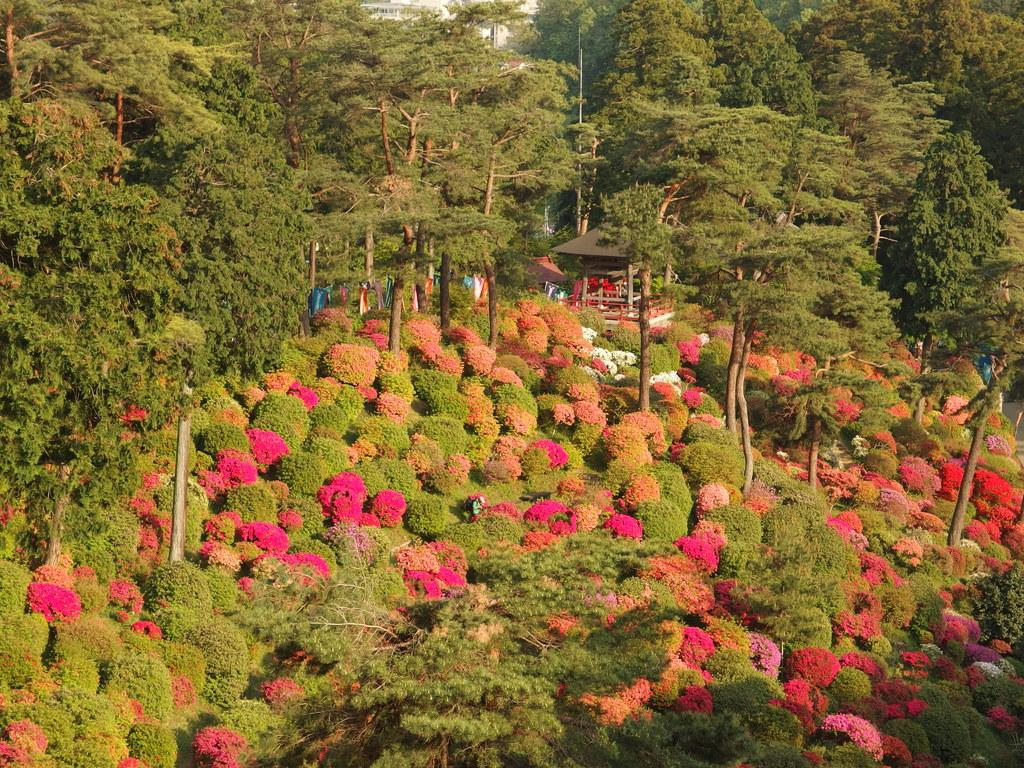What type of location is shown in the image? The image depicts a garden. What can be seen at the bottom of the image? There are many flower plants at the bottom of the image. What is visible in the background of the image? There are trees and a shed in the background of the image. Are there any people present in the image? Yes, there are people in the background of the image. What type of thread is being used by the people in the image? There is no thread visible in the image, as it depicts a garden with people in the background. What organization is responsible for maintaining the garden in the image? The image does not provide information about the organization responsible for maintaining the garden. 